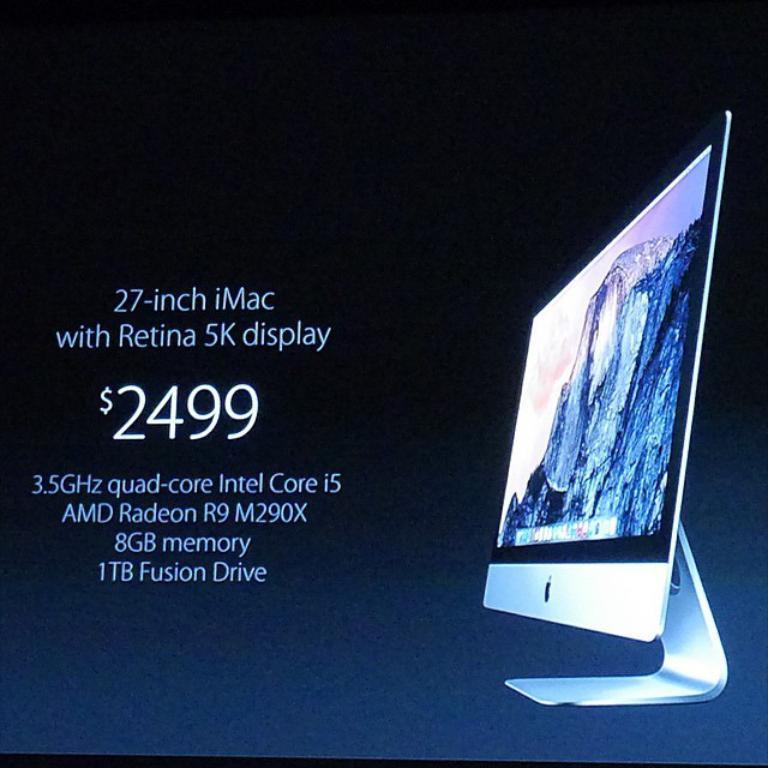<image>
Render a clear and concise summary of the photo. A blue advertisement for a 27 inch iMac computer with a 5K retina display. 